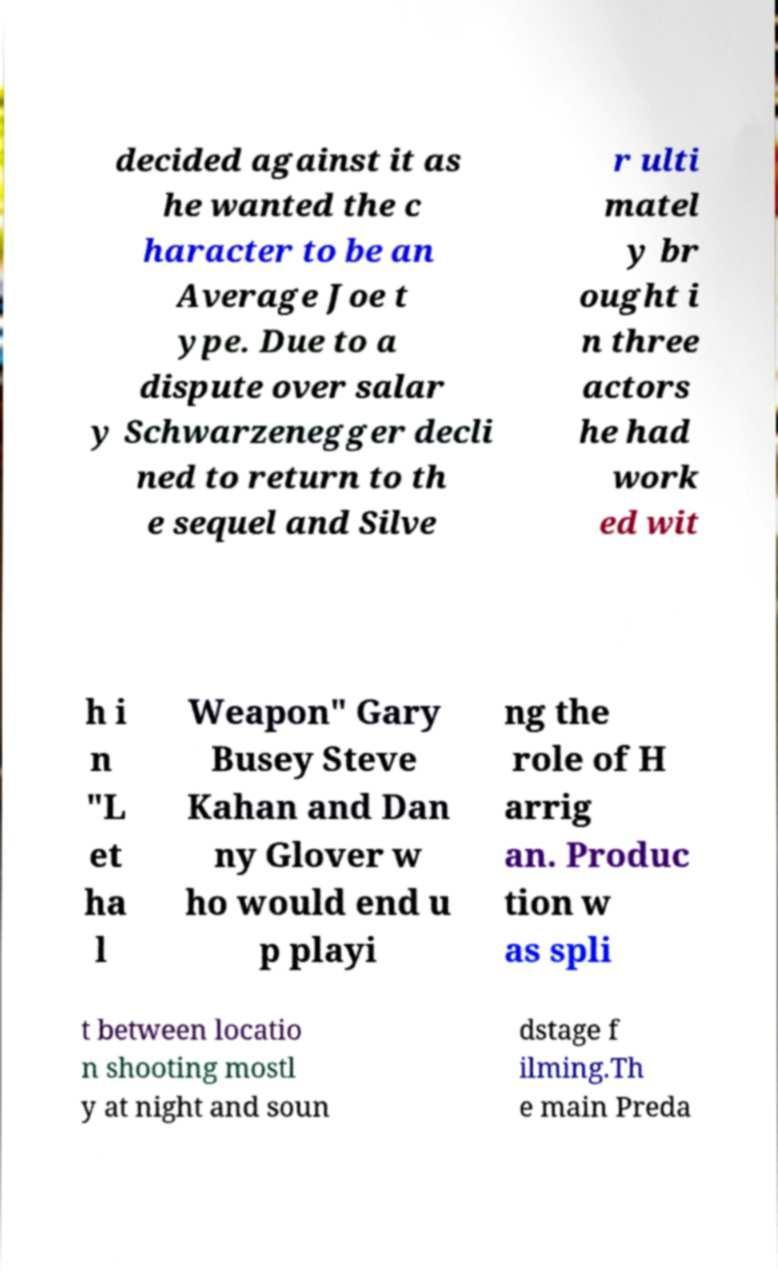Can you read and provide the text displayed in the image?This photo seems to have some interesting text. Can you extract and type it out for me? decided against it as he wanted the c haracter to be an Average Joe t ype. Due to a dispute over salar y Schwarzenegger decli ned to return to th e sequel and Silve r ulti matel y br ought i n three actors he had work ed wit h i n "L et ha l Weapon" Gary Busey Steve Kahan and Dan ny Glover w ho would end u p playi ng the role of H arrig an. Produc tion w as spli t between locatio n shooting mostl y at night and soun dstage f ilming.Th e main Preda 